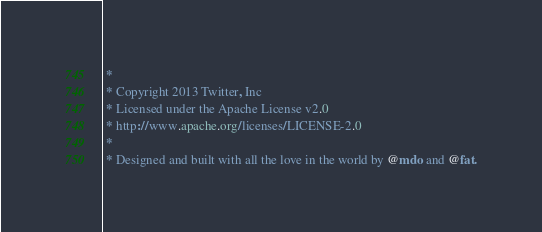Convert code to text. <code><loc_0><loc_0><loc_500><loc_500><_CSS_> *
 * Copyright 2013 Twitter, Inc
 * Licensed under the Apache License v2.0
 * http://www.apache.org/licenses/LICENSE-2.0
 *
 * Designed and built with all the love in the world by @mdo and @fat.</code> 